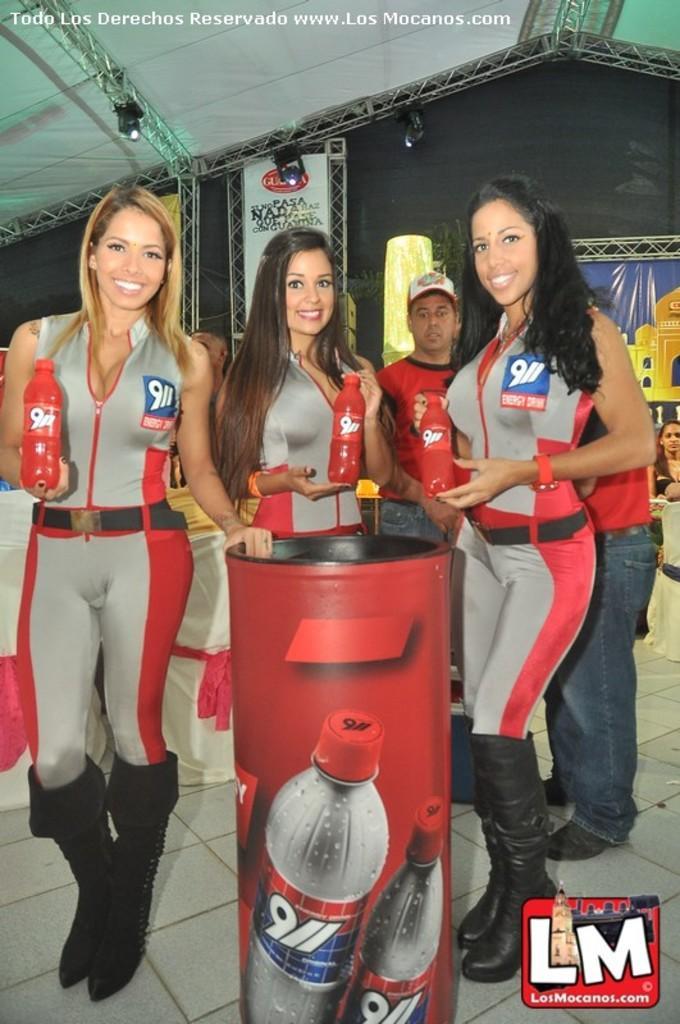Can you describe this image briefly? In this picture we can see group of people and few people holding bottles, in the middle of the image we can see a box, in the background we can find few metal rods, lights and a hoarding, in the bottom right hand corner we can see a logo, in the top left hand corner we can find some text. 